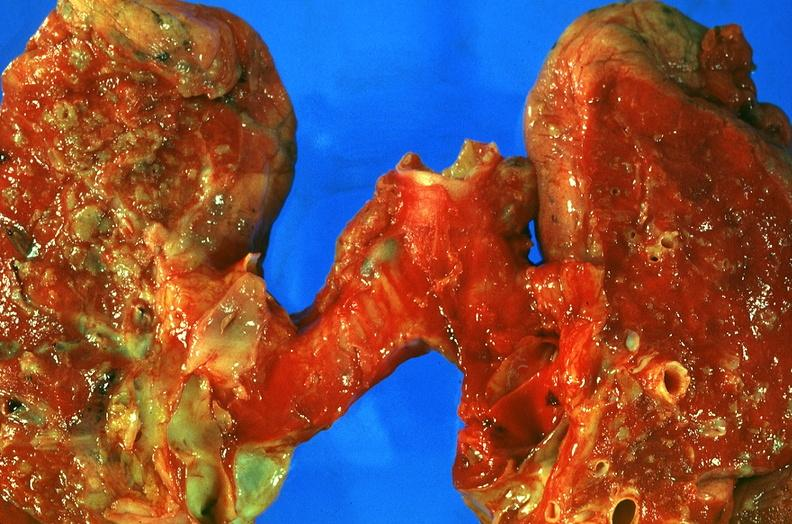does this image show lung, sarcoidosis?
Answer the question using a single word or phrase. Yes 